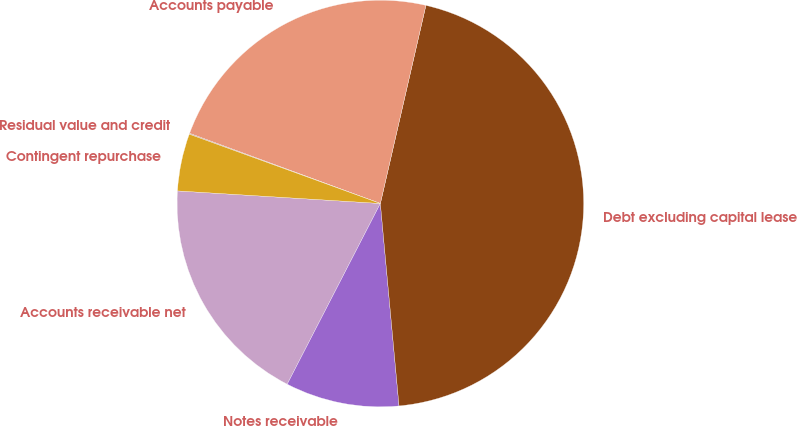<chart> <loc_0><loc_0><loc_500><loc_500><pie_chart><fcel>Accounts receivable net<fcel>Notes receivable<fcel>Debt excluding capital lease<fcel>Accounts payable<fcel>Residual value and credit<fcel>Contingent repurchase<nl><fcel>18.41%<fcel>9.04%<fcel>44.94%<fcel>22.99%<fcel>0.07%<fcel>4.55%<nl></chart> 